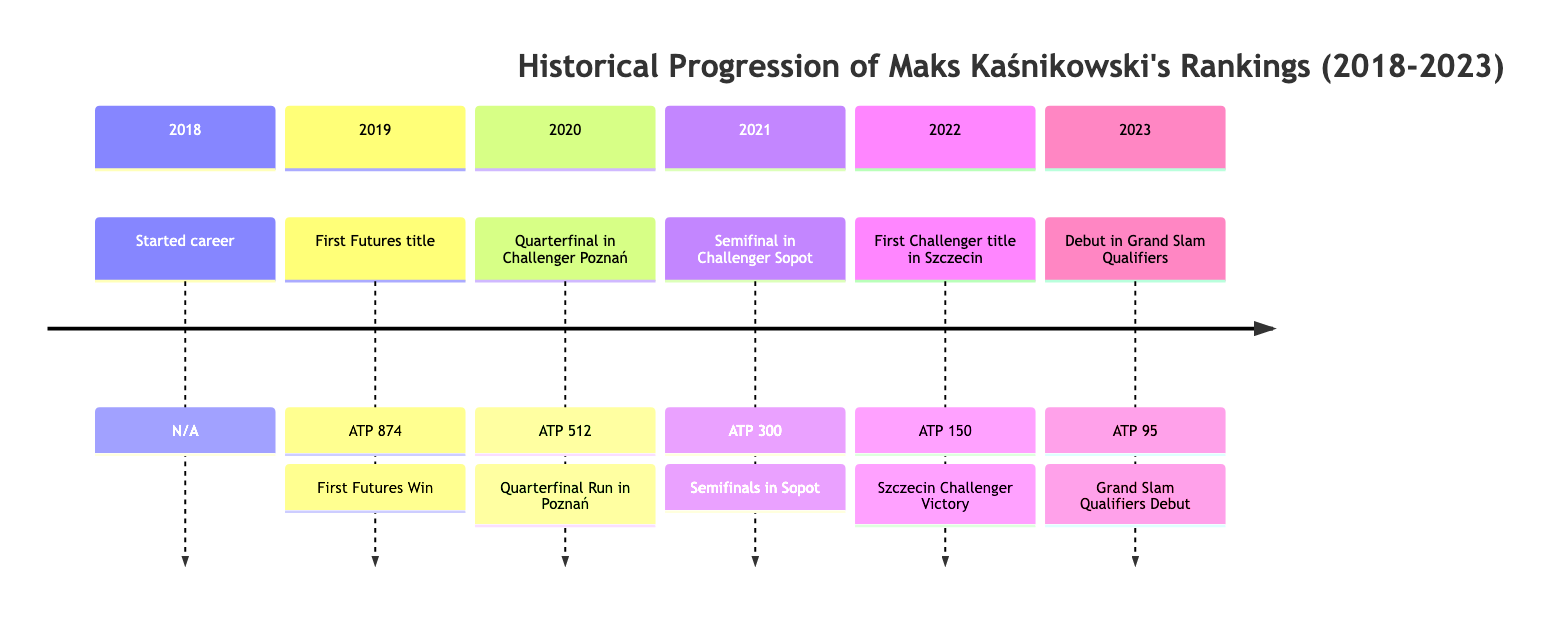What ranking did Maks Kaśnikowski achieve in 2019? In 2019, the diagram shows that Maks Kaśnikowski achieved an ATP ranking of 874, marking his first Futures title.
Answer: ATP 874 What year did Maks Kaśnikowski reach ATP 512? The diagram indicates that in 2020, Maks Kaśnikowski reached ATP 512, coinciding with his quarterfinal appearance in the Challenger Poznań.
Answer: ATP 512 How many titles did Maks Kaśnikowski claim in his career by 2022? By 2022, the diagram highlights that he achieved his first Challenger title, which suggests he has one title at that point.
Answer: 1 In which city did Maks Kaśnikowski win his first Challenger title? The diagram specifies that Maks Kaśnikowski won his first Challenger title in Szczecin in 2022.
Answer: Szczecin What is the highest ranking achieved by Maks Kaśnikowski as of 2023? According to the diagram, his highest ranking as of 2023 is ATP 95, following his debut in Grand Slam Qualifiers.
Answer: ATP 95 What was the key event leading to the ATP 300 ranking in 2021? The diagram states that the key event that led to his ATP 300 ranking was making it to the semifinals in Challenger Sopot.
Answer: Semifinals in Sopot Which year marks the debut of Maks Kaśnikowski in Grand Slam Qualifiers? Based on the diagram, Maks Kaśnikowski made his debut in Grand Slam Qualifiers in 2023.
Answer: 2023 What was Maks Kaśnikowski's ranking when he reached the quarterfinals in Poznań? The diagram notes that when he reached the quarterfinals in Poznań in 2020, his ranking was ATP 512.
Answer: ATP 512 